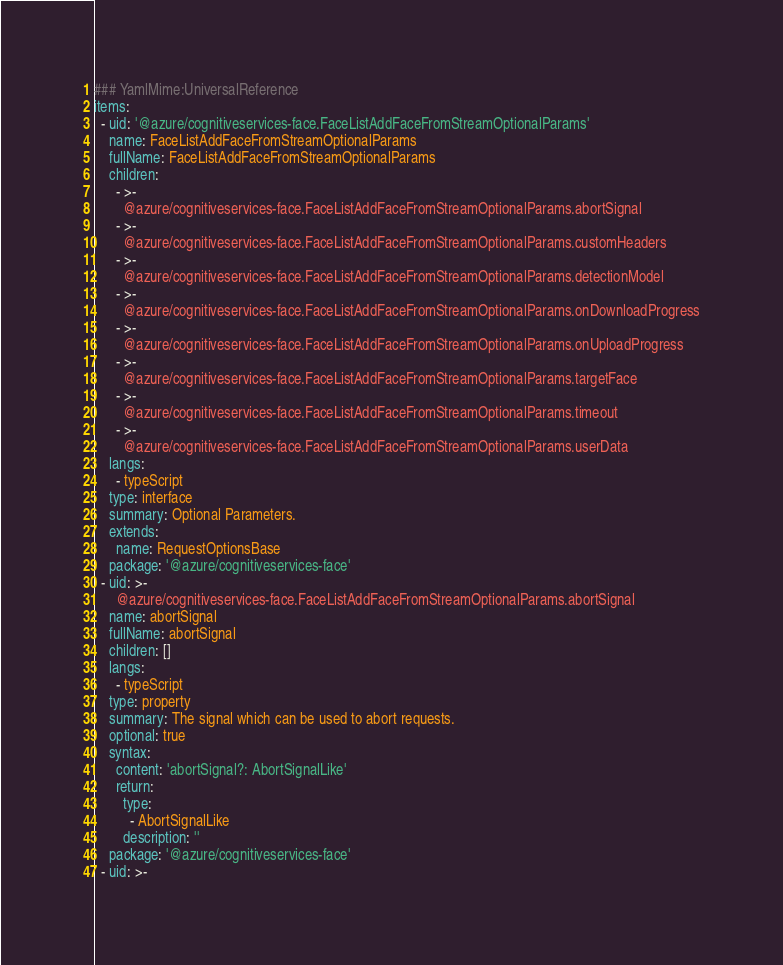<code> <loc_0><loc_0><loc_500><loc_500><_YAML_>### YamlMime:UniversalReference
items:
  - uid: '@azure/cognitiveservices-face.FaceListAddFaceFromStreamOptionalParams'
    name: FaceListAddFaceFromStreamOptionalParams
    fullName: FaceListAddFaceFromStreamOptionalParams
    children:
      - >-
        @azure/cognitiveservices-face.FaceListAddFaceFromStreamOptionalParams.abortSignal
      - >-
        @azure/cognitiveservices-face.FaceListAddFaceFromStreamOptionalParams.customHeaders
      - >-
        @azure/cognitiveservices-face.FaceListAddFaceFromStreamOptionalParams.detectionModel
      - >-
        @azure/cognitiveservices-face.FaceListAddFaceFromStreamOptionalParams.onDownloadProgress
      - >-
        @azure/cognitiveservices-face.FaceListAddFaceFromStreamOptionalParams.onUploadProgress
      - >-
        @azure/cognitiveservices-face.FaceListAddFaceFromStreamOptionalParams.targetFace
      - >-
        @azure/cognitiveservices-face.FaceListAddFaceFromStreamOptionalParams.timeout
      - >-
        @azure/cognitiveservices-face.FaceListAddFaceFromStreamOptionalParams.userData
    langs:
      - typeScript
    type: interface
    summary: Optional Parameters.
    extends:
      name: RequestOptionsBase
    package: '@azure/cognitiveservices-face'
  - uid: >-
      @azure/cognitiveservices-face.FaceListAddFaceFromStreamOptionalParams.abortSignal
    name: abortSignal
    fullName: abortSignal
    children: []
    langs:
      - typeScript
    type: property
    summary: The signal which can be used to abort requests.
    optional: true
    syntax:
      content: 'abortSignal?: AbortSignalLike'
      return:
        type:
          - AbortSignalLike
        description: ''
    package: '@azure/cognitiveservices-face'
  - uid: >-</code> 